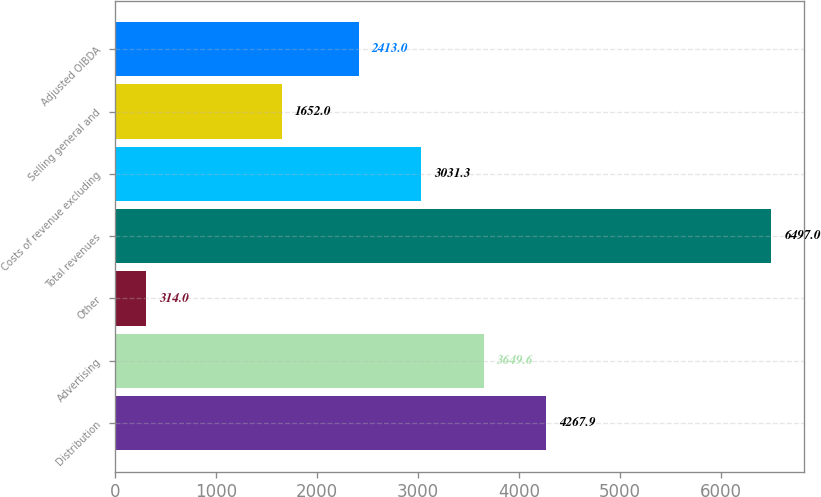Convert chart. <chart><loc_0><loc_0><loc_500><loc_500><bar_chart><fcel>Distribution<fcel>Advertising<fcel>Other<fcel>Total revenues<fcel>Costs of revenue excluding<fcel>Selling general and<fcel>Adjusted OIBDA<nl><fcel>4267.9<fcel>3649.6<fcel>314<fcel>6497<fcel>3031.3<fcel>1652<fcel>2413<nl></chart> 